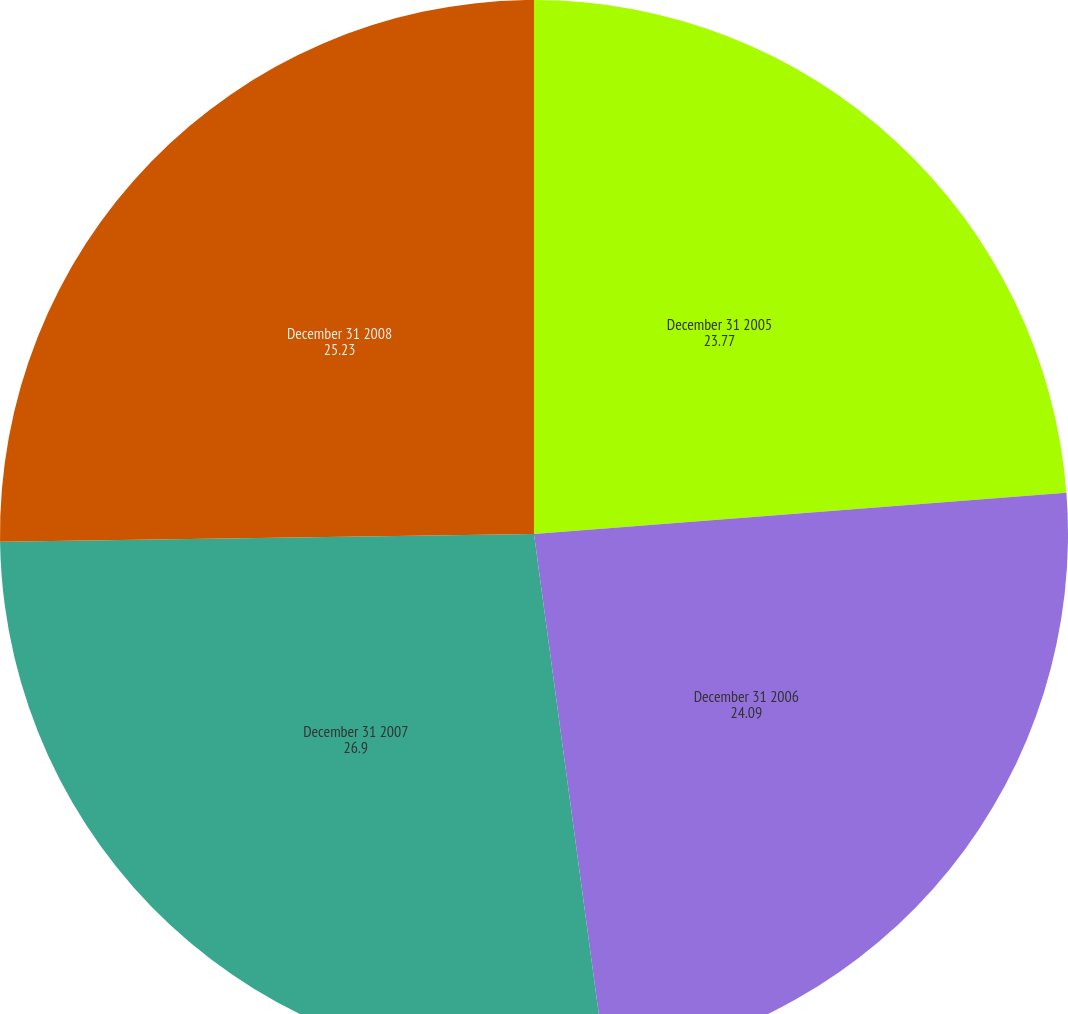Convert chart to OTSL. <chart><loc_0><loc_0><loc_500><loc_500><pie_chart><fcel>December 31 2005<fcel>December 31 2006<fcel>December 31 2007<fcel>December 31 2008<nl><fcel>23.77%<fcel>24.09%<fcel>26.9%<fcel>25.23%<nl></chart> 